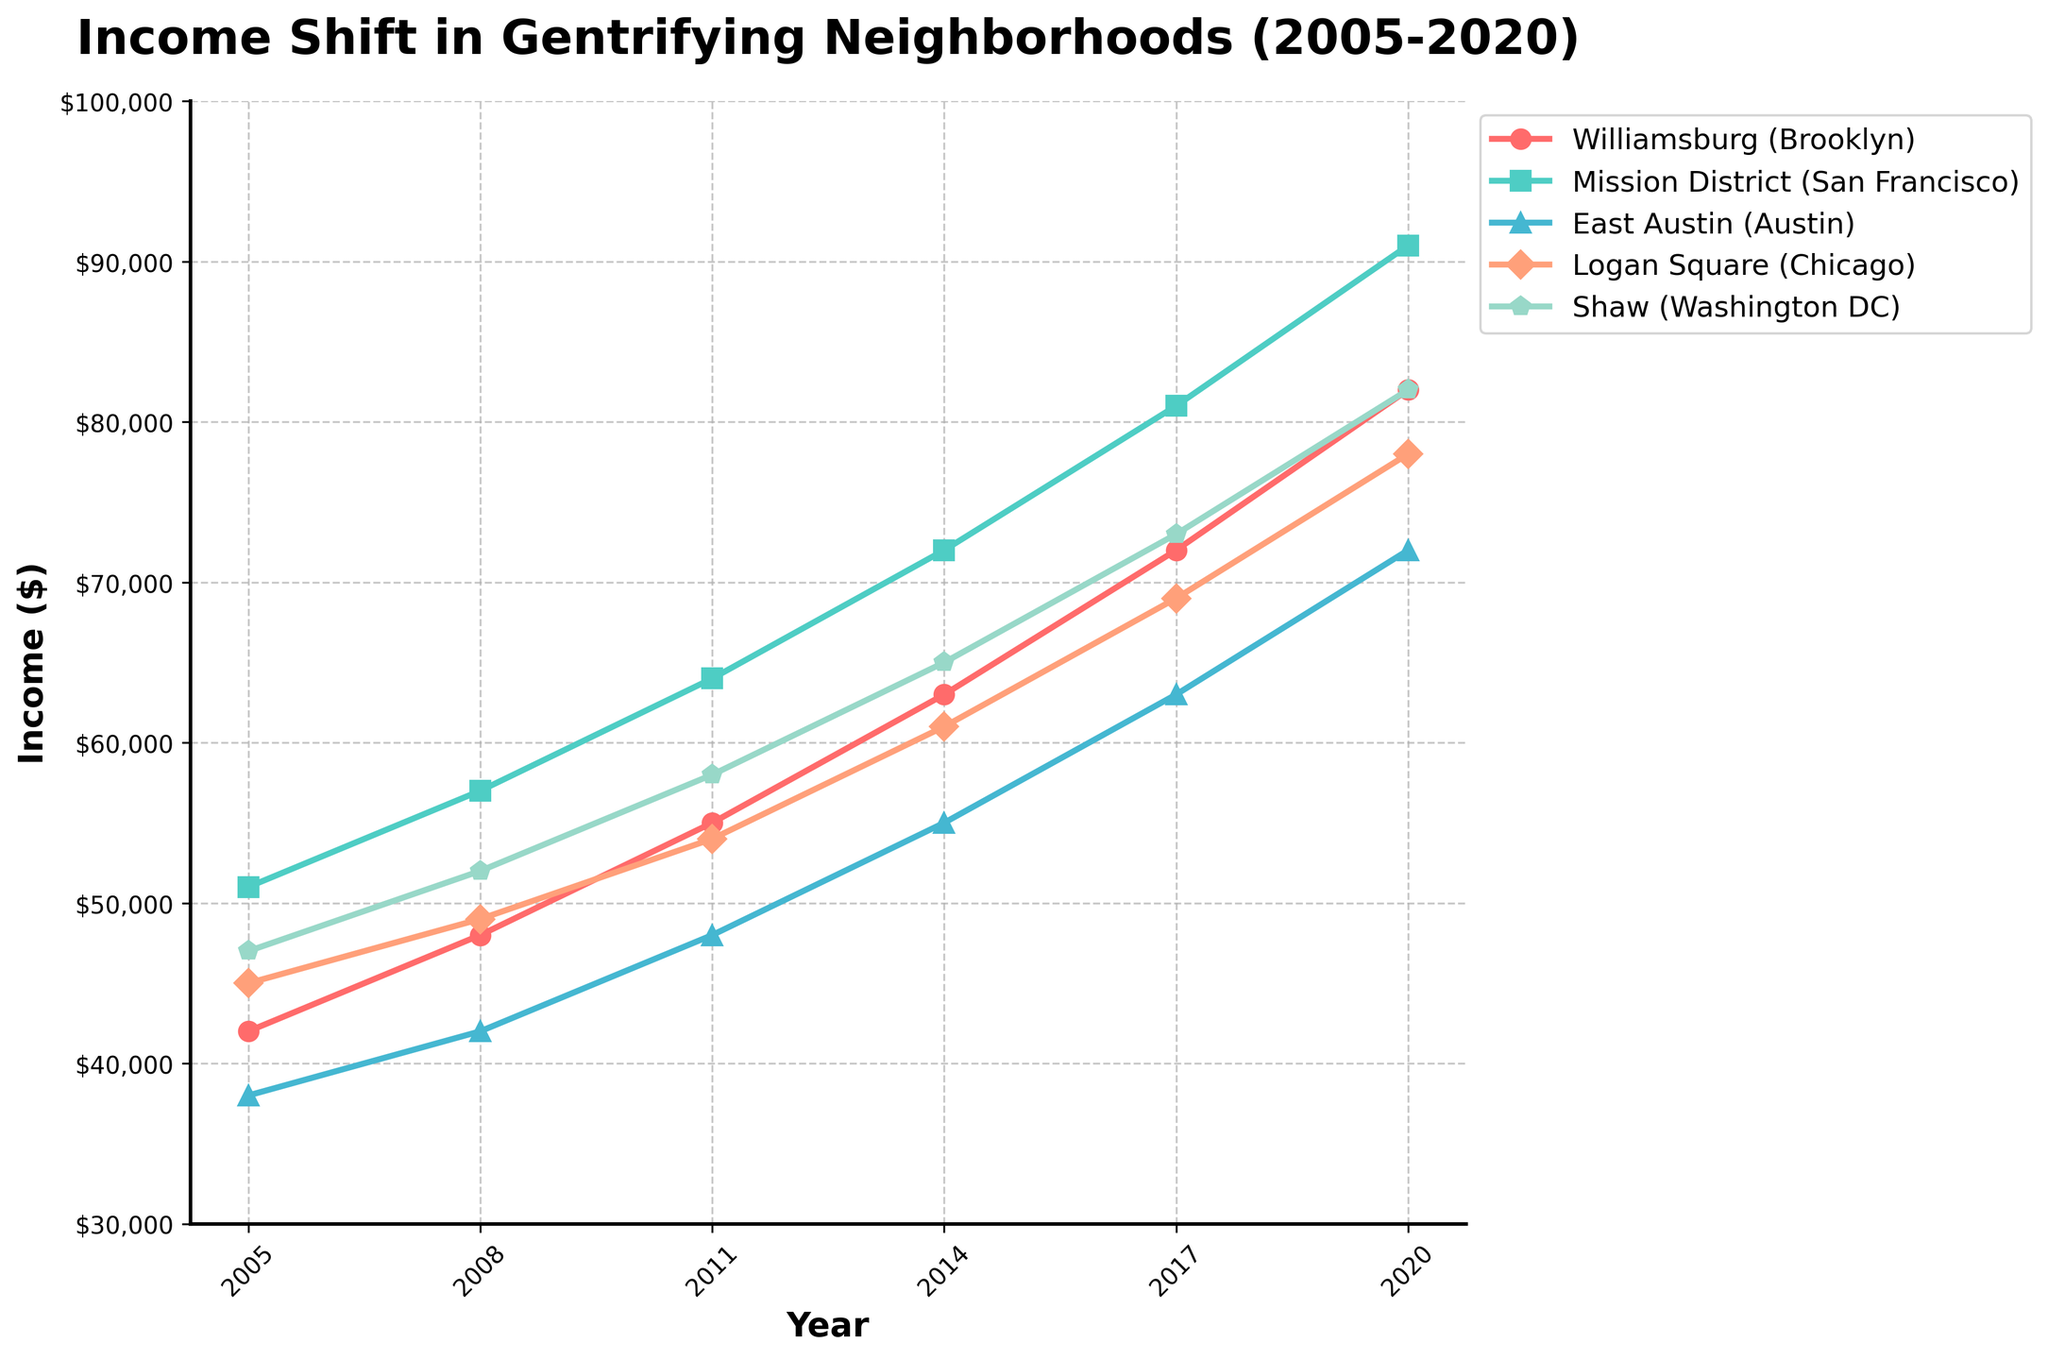What is the overall trend in income levels for Williamsburg (Brooklyn) from 2005 to 2020? Identify the data points for Williamsburg in each year, then observe the direction of change. From 2005 to 2020, the income levels increase.
Answer: Increasing Which neighborhood had the highest income level in 2014? Look at the income levels for each neighborhood in 2014: Williamsburg ($63,000), Mission District ($72,000), East Austin ($55,000), Logan Square ($61,000), Shaw ($65,000). The highest among these is Mission District.
Answer: Mission District How many neighborhoods had an income level above $70,000 in 2020? Check the income levels for each neighborhood in 2020: Williamsburg ($82,000), Mission District ($91,000), East Austin ($72,000), Logan Square ($78,000), Shaw ($82,000). Count the number of neighborhoods above $70,000, which are all 5 in this case.
Answer: 5 By how much did the income level in East Austin increase from 2005 to 2020? Subtract the income level in 2005 ($38,000) from the income level in 2020 ($72,000) for East Austin. The difference is $34,000.
Answer: $34,000 Which neighborhood showed the biggest increase in income levels over the 15-year period? Calculate the increase for each neighborhood: Williamsburg ($82,000 - $42,000 = $40,000), Mission District ($91,000 - $51,000 = $40,000), East Austin ($72,000 - $38,000 = $34,000), Logan Square ($78,000 - $45,000 = $33,000), Shaw ($82,000 - $47,000 = $35,000). The biggest increase is tied between Williamsburg and Mission District, both at $40,000.
Answer: Williamsburg and Mission District In what year did Logan Square's income level first surpass Shaw's? Compare the income levels year by year: In 2005, Logan Square ($45,000) < Shaw ($47,000); in 2008, Logan Square ($49,000) < Shaw ($52,000); in 2011, Logan Square ($54,000) < Shaw ($58,000); in 2014, Logan Square ($61,000) < Shaw ($65,000); in 2017, Logan Square ($69,000) < Shaw ($73,000); and finally in 2020, Logan Square ($78,000) < Shaw ($82,000). Logan Square's income level never surpasses Shaw's throughout the given period.
Answer: Never What was the percentage increase in income for the Mission District from 2008 to 2014? Calculate the percentage increase: ((72,000 - 57,000) / 57,000) * 100 = (15,000 / 57,000) * 100 ≈ 26.32%.
Answer: 26.32% Which neighborhood had the smallest income level in 2005 and what was it? Identify the income levels in 2005: Williamsburg ($42,000), Mission District ($51,000), East Austin ($38,000), Logan Square ($45,000), Shaw ($47,000). The smallest income level was in East Austin with $38,000.
Answer: East Austin with $38,000 What is the average income level in 2011 across all neighborhoods? Sum the income levels for all neighborhoods in 2011 and divide by the number of neighborhoods: (55,000 + 64,000 + 48,000 + 54,000 + 58,000) / 5 = 279,000 / 5 = 55,800.
Answer: $55,800 